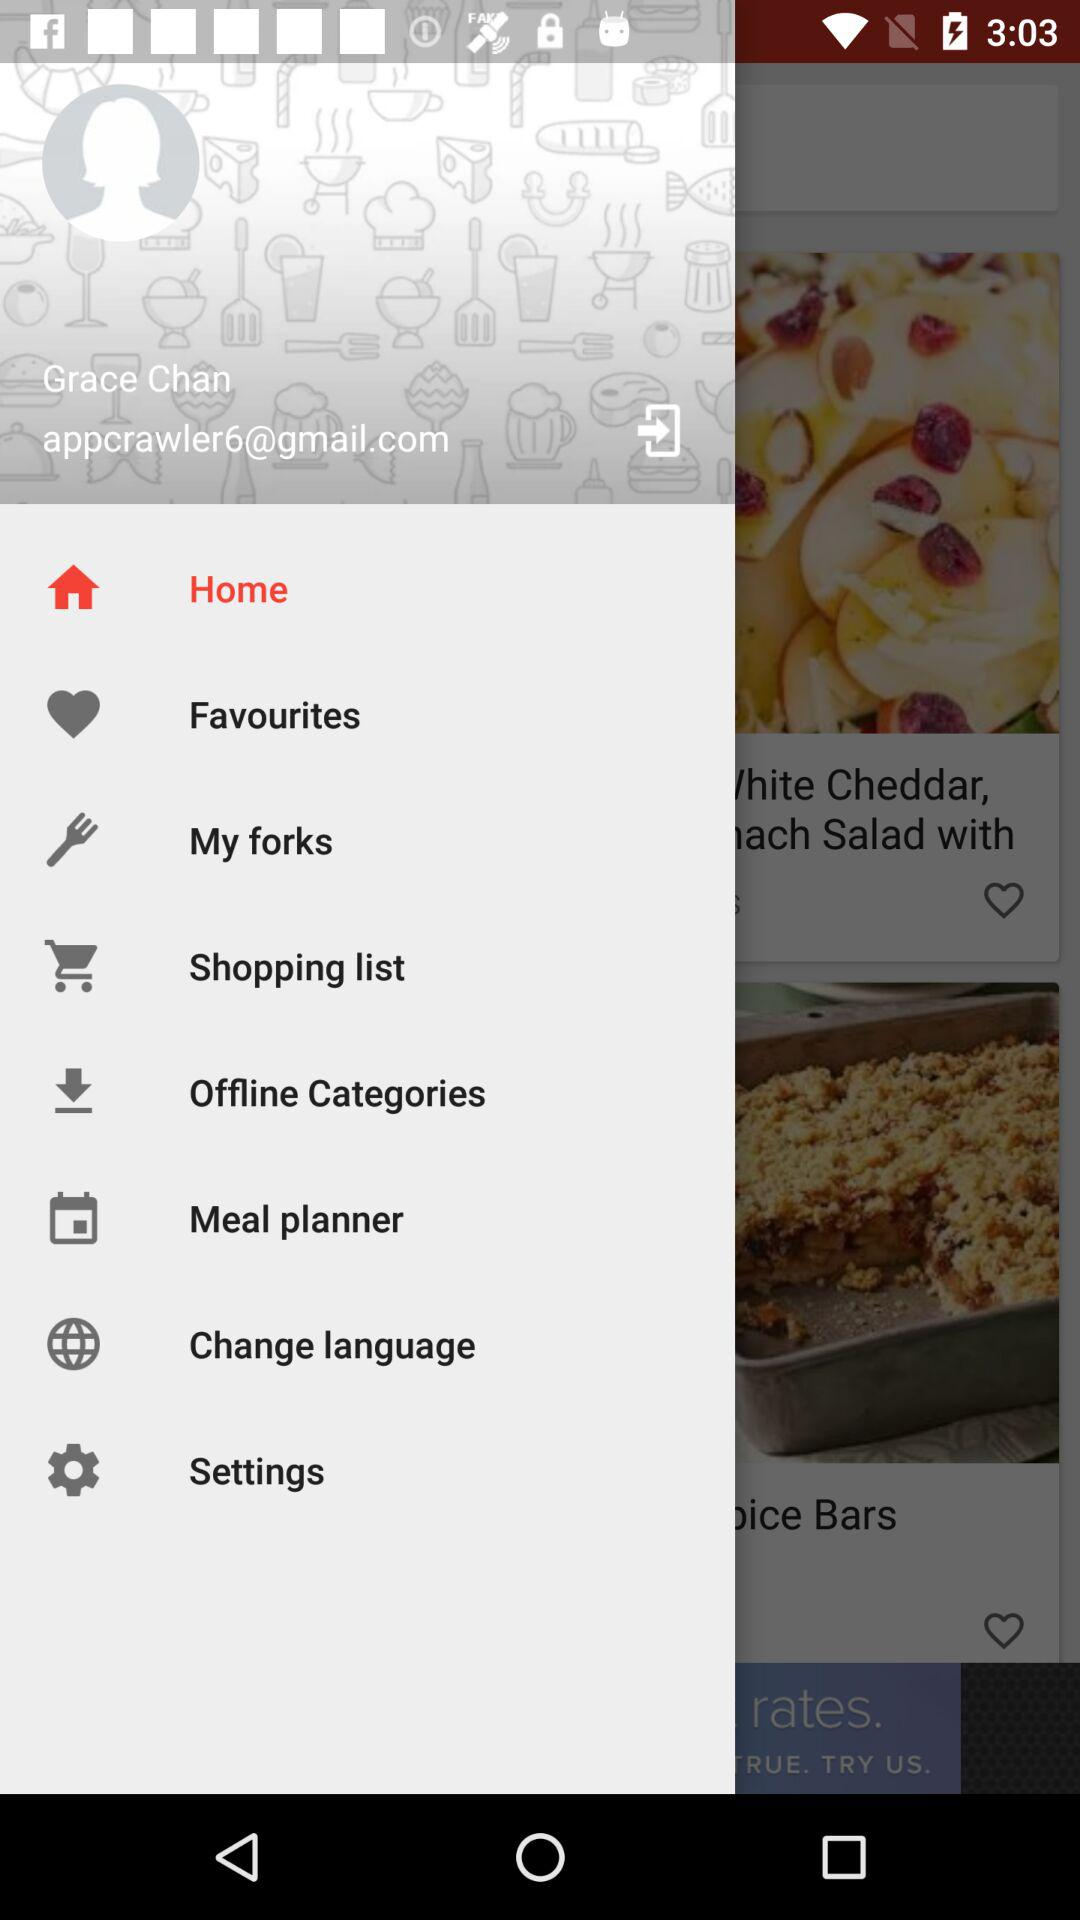What is the email address? The email address is appcrawler6@gmail.com. 